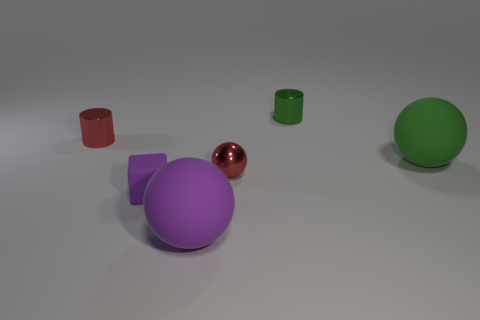Are there any large things of the same color as the small cube?
Offer a terse response. Yes. What color is the rubber ball that is to the left of the big matte sphere behind the small block?
Keep it short and to the point. Purple. What size is the green thing that is in front of the metal thing that is on the left side of the large matte ball in front of the purple matte cube?
Your answer should be very brief. Large. Is the tiny sphere made of the same material as the cylinder to the right of the big purple rubber object?
Provide a succinct answer. Yes. What is the size of the ball that is made of the same material as the large green object?
Your answer should be compact. Large. Is there a red metal thing that has the same shape as the green matte thing?
Offer a terse response. Yes. What number of objects are either big objects on the right side of the green metal cylinder or brown metal objects?
Your answer should be very brief. 1. What is the size of the object that is the same color as the tiny cube?
Offer a very short reply. Large. Is the color of the matte thing to the right of the big purple matte thing the same as the cylinder right of the purple matte sphere?
Your answer should be compact. Yes. The green metal object is what size?
Your response must be concise. Small. 